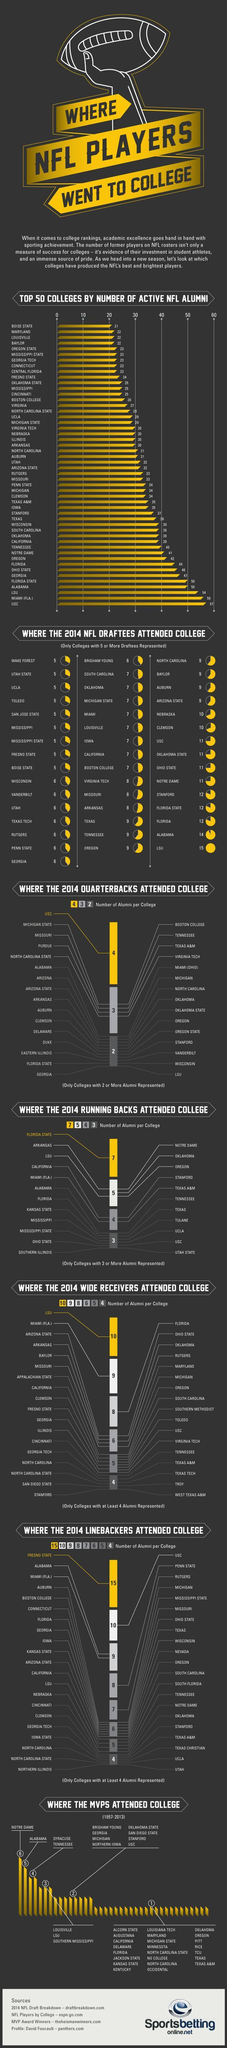How many colleges had atleast 4 MVPS attend?
Answer the question with a short phrase. 4 How many colleges represented more than 10 NFL Draftees in 2014? 9 Which college did the most number of 2014 Quarterbacks attend? USC Which college had 27 Active NFL Alumni? Virginia How many colleges had more than 25 Active NFL Alumni? 37 Which college had the most number of NFL Draftees in 2014? LSU Which college did the most number of 2014 Running backs attend? Florida State How many colleges had more than 50 Active NFL Alumni? 3 What is the number of Active NFL Alumni from USC and Miami(FLA) put together? 113 Which college had lowest number of Active NFL Alumni? Boise State 